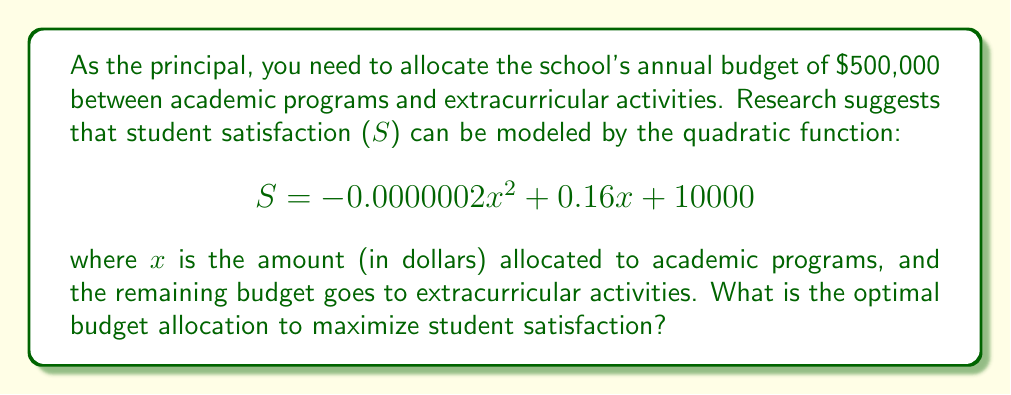Can you answer this question? To find the optimal budget allocation, we need to maximize the quadratic function:

1) First, we need to find the vertex of the parabola, which represents the maximum point. For a quadratic function in the form $f(x) = ax^2 + bx + c$, the x-coordinate of the vertex is given by $x = -\frac{b}{2a}$.

2) In our function, $a = -0.0000002$ and $b = 0.16$. Let's calculate:

   $x = -\frac{0.16}{2(-0.0000002)} = 400,000$

3) This means that allocating $400,000 to academic programs will maximize student satisfaction.

4) To verify this is within our budget constraint:
   $400,000 < 500,000$, so this allocation is feasible.

5) The remaining budget will go to extracurricular activities:
   $500,000 - 400,000 = 100,000$

Therefore, the optimal allocation is $400,000 for academic programs and $100,000 for extracurricular activities.
Answer: $400,000 for academic programs, $100,000 for extracurricular activities 